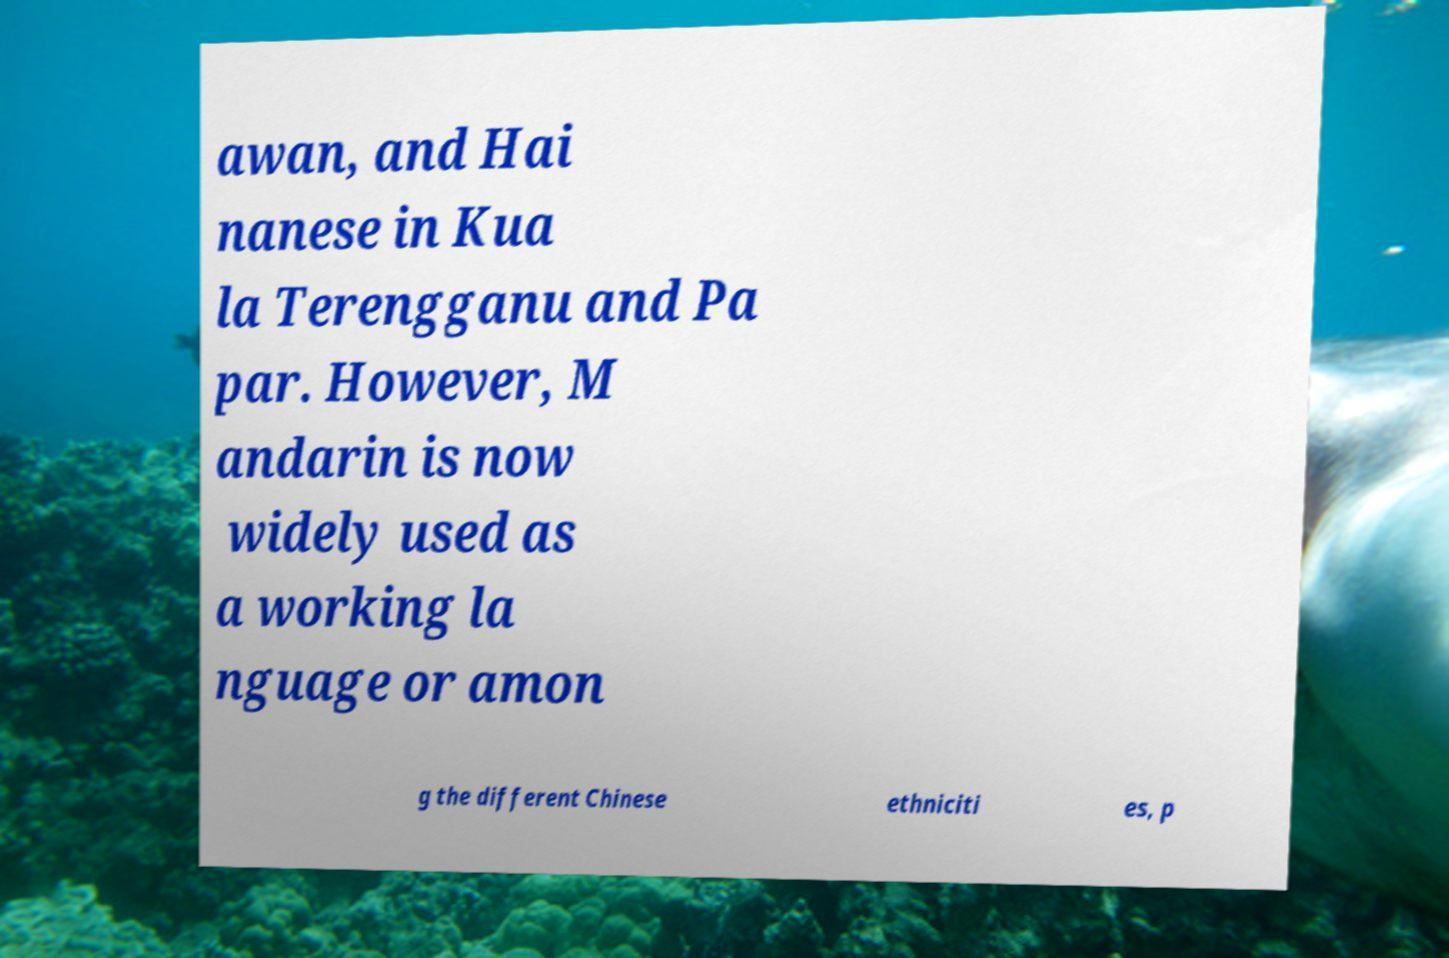What messages or text are displayed in this image? I need them in a readable, typed format. awan, and Hai nanese in Kua la Terengganu and Pa par. However, M andarin is now widely used as a working la nguage or amon g the different Chinese ethniciti es, p 